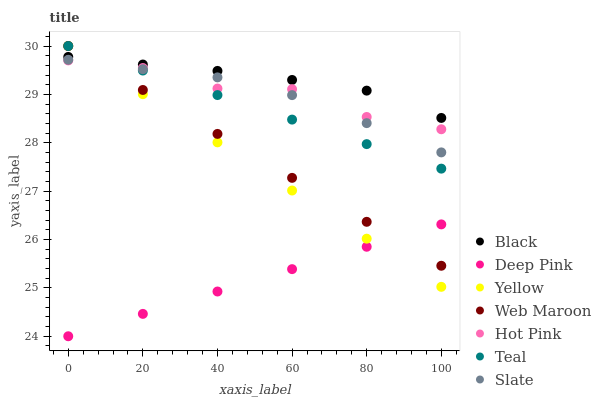Does Deep Pink have the minimum area under the curve?
Answer yes or no. Yes. Does Black have the maximum area under the curve?
Answer yes or no. Yes. Does Slate have the minimum area under the curve?
Answer yes or no. No. Does Slate have the maximum area under the curve?
Answer yes or no. No. Is Deep Pink the smoothest?
Answer yes or no. Yes. Is Hot Pink the roughest?
Answer yes or no. Yes. Is Slate the smoothest?
Answer yes or no. No. Is Slate the roughest?
Answer yes or no. No. Does Deep Pink have the lowest value?
Answer yes or no. Yes. Does Slate have the lowest value?
Answer yes or no. No. Does Teal have the highest value?
Answer yes or no. Yes. Does Slate have the highest value?
Answer yes or no. No. Is Deep Pink less than Hot Pink?
Answer yes or no. Yes. Is Black greater than Deep Pink?
Answer yes or no. Yes. Does Teal intersect Web Maroon?
Answer yes or no. Yes. Is Teal less than Web Maroon?
Answer yes or no. No. Is Teal greater than Web Maroon?
Answer yes or no. No. Does Deep Pink intersect Hot Pink?
Answer yes or no. No. 